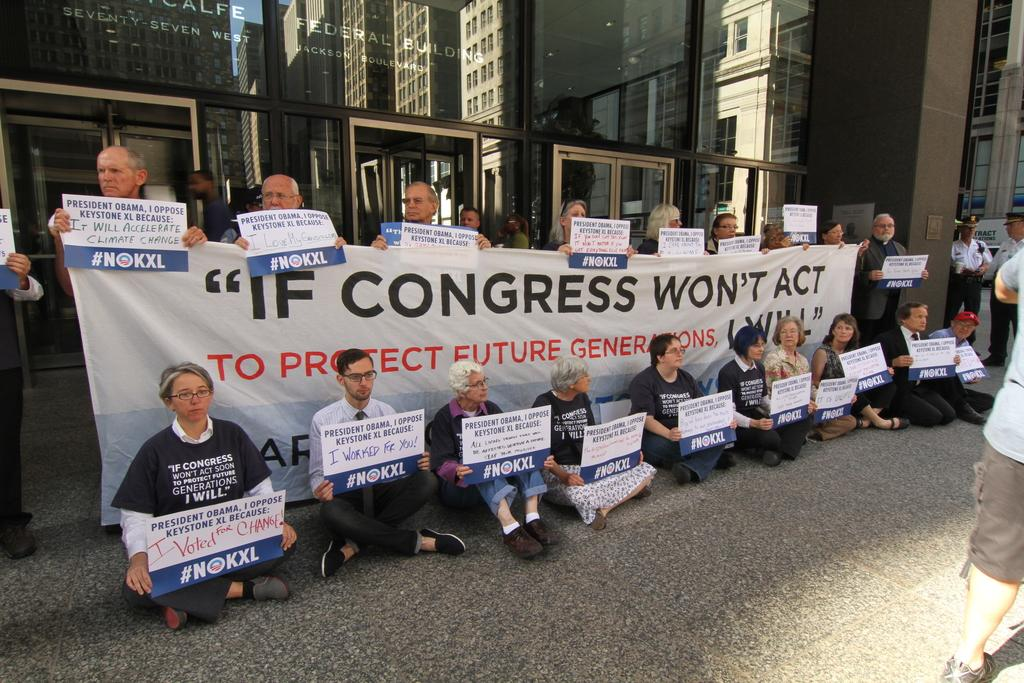What are the people in the image doing? The people in the image are standing and sitting, and they are holding banners. What might the banners signify? The banners might signify a cause, event, or message that the people are supporting or promoting. What can be seen in the background of the image? There is a building in the background of the image. How many mice can be seen running around on the fifth floor of the building in the image? There are no mice present in the image, and the image does not provide information about the floors of the building. 